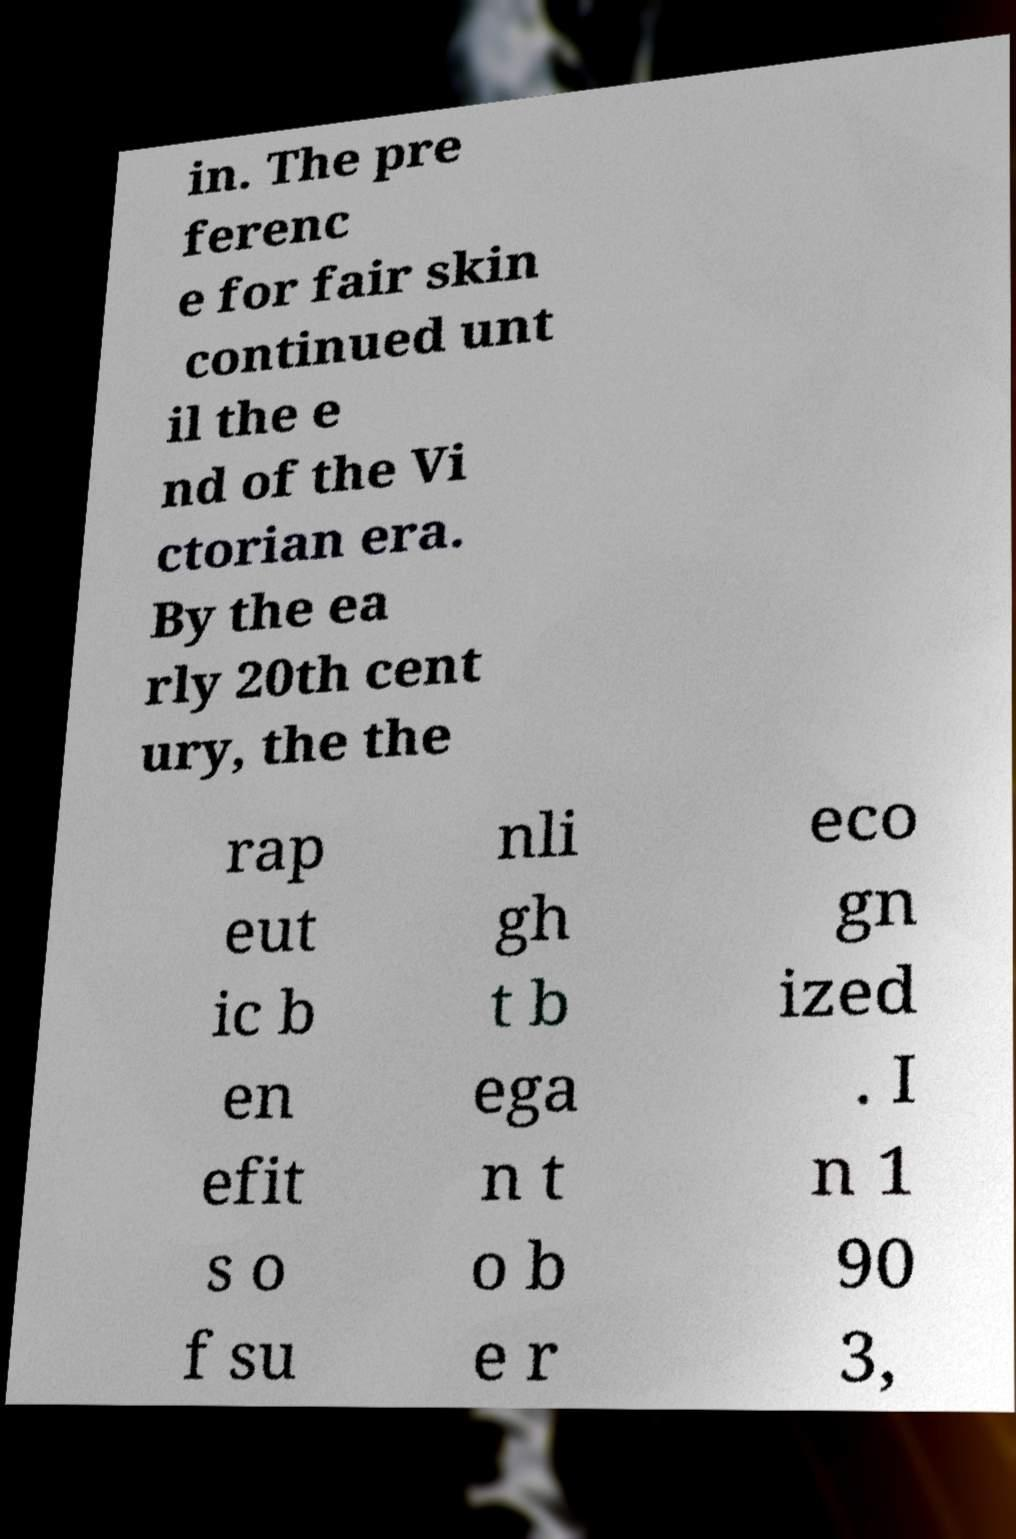I need the written content from this picture converted into text. Can you do that? in. The pre ferenc e for fair skin continued unt il the e nd of the Vi ctorian era. By the ea rly 20th cent ury, the the rap eut ic b en efit s o f su nli gh t b ega n t o b e r eco gn ized . I n 1 90 3, 